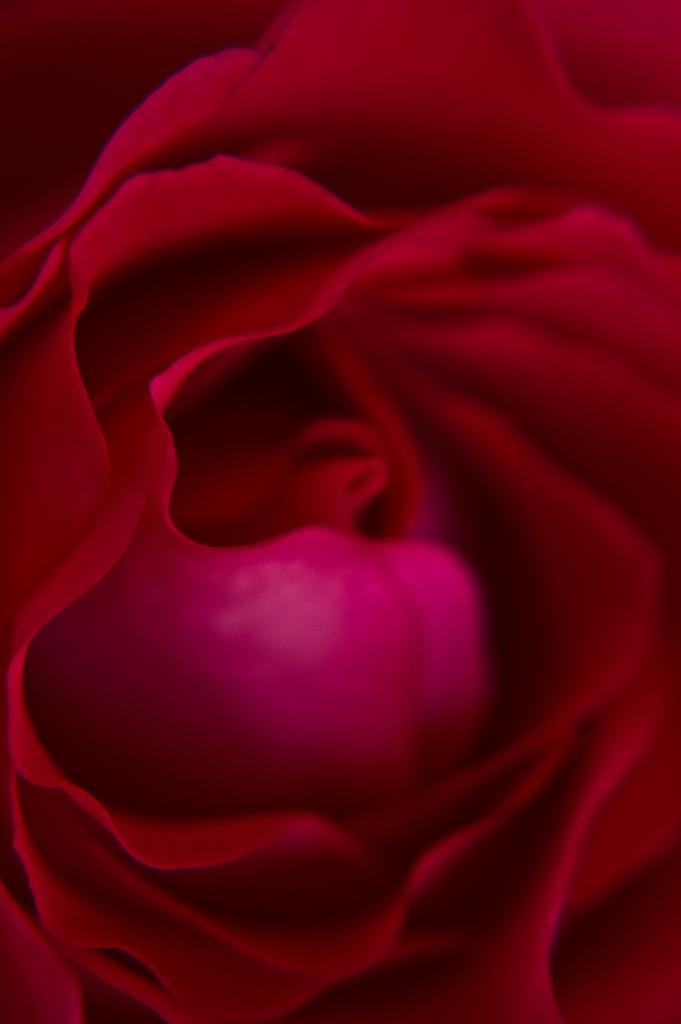What is the main subject of the image? There is a flower in the image. Can you describe the color of the flower? The flower is red in color. What type of wren can be seen singing in the image? There is no wren present in the image; it only features a red flower. 